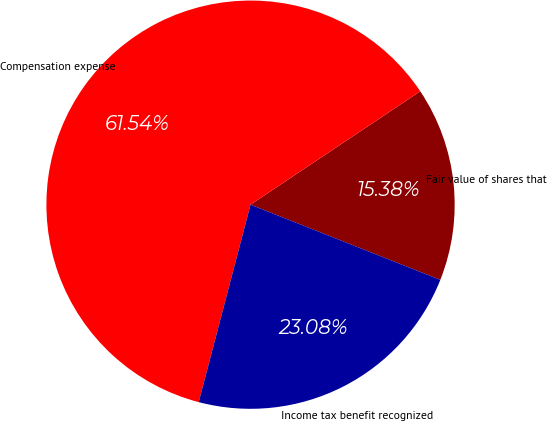<chart> <loc_0><loc_0><loc_500><loc_500><pie_chart><fcel>Fair value of shares that<fcel>Compensation expense<fcel>Income tax benefit recognized<nl><fcel>15.38%<fcel>61.54%<fcel>23.08%<nl></chart> 